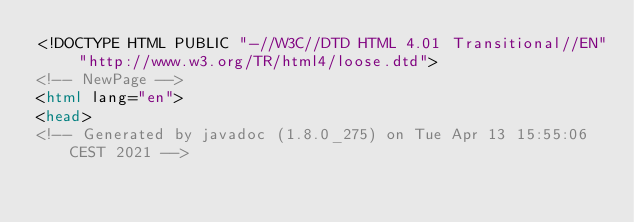Convert code to text. <code><loc_0><loc_0><loc_500><loc_500><_HTML_><!DOCTYPE HTML PUBLIC "-//W3C//DTD HTML 4.01 Transitional//EN" "http://www.w3.org/TR/html4/loose.dtd">
<!-- NewPage -->
<html lang="en">
<head>
<!-- Generated by javadoc (1.8.0_275) on Tue Apr 13 15:55:06 CEST 2021 --></code> 